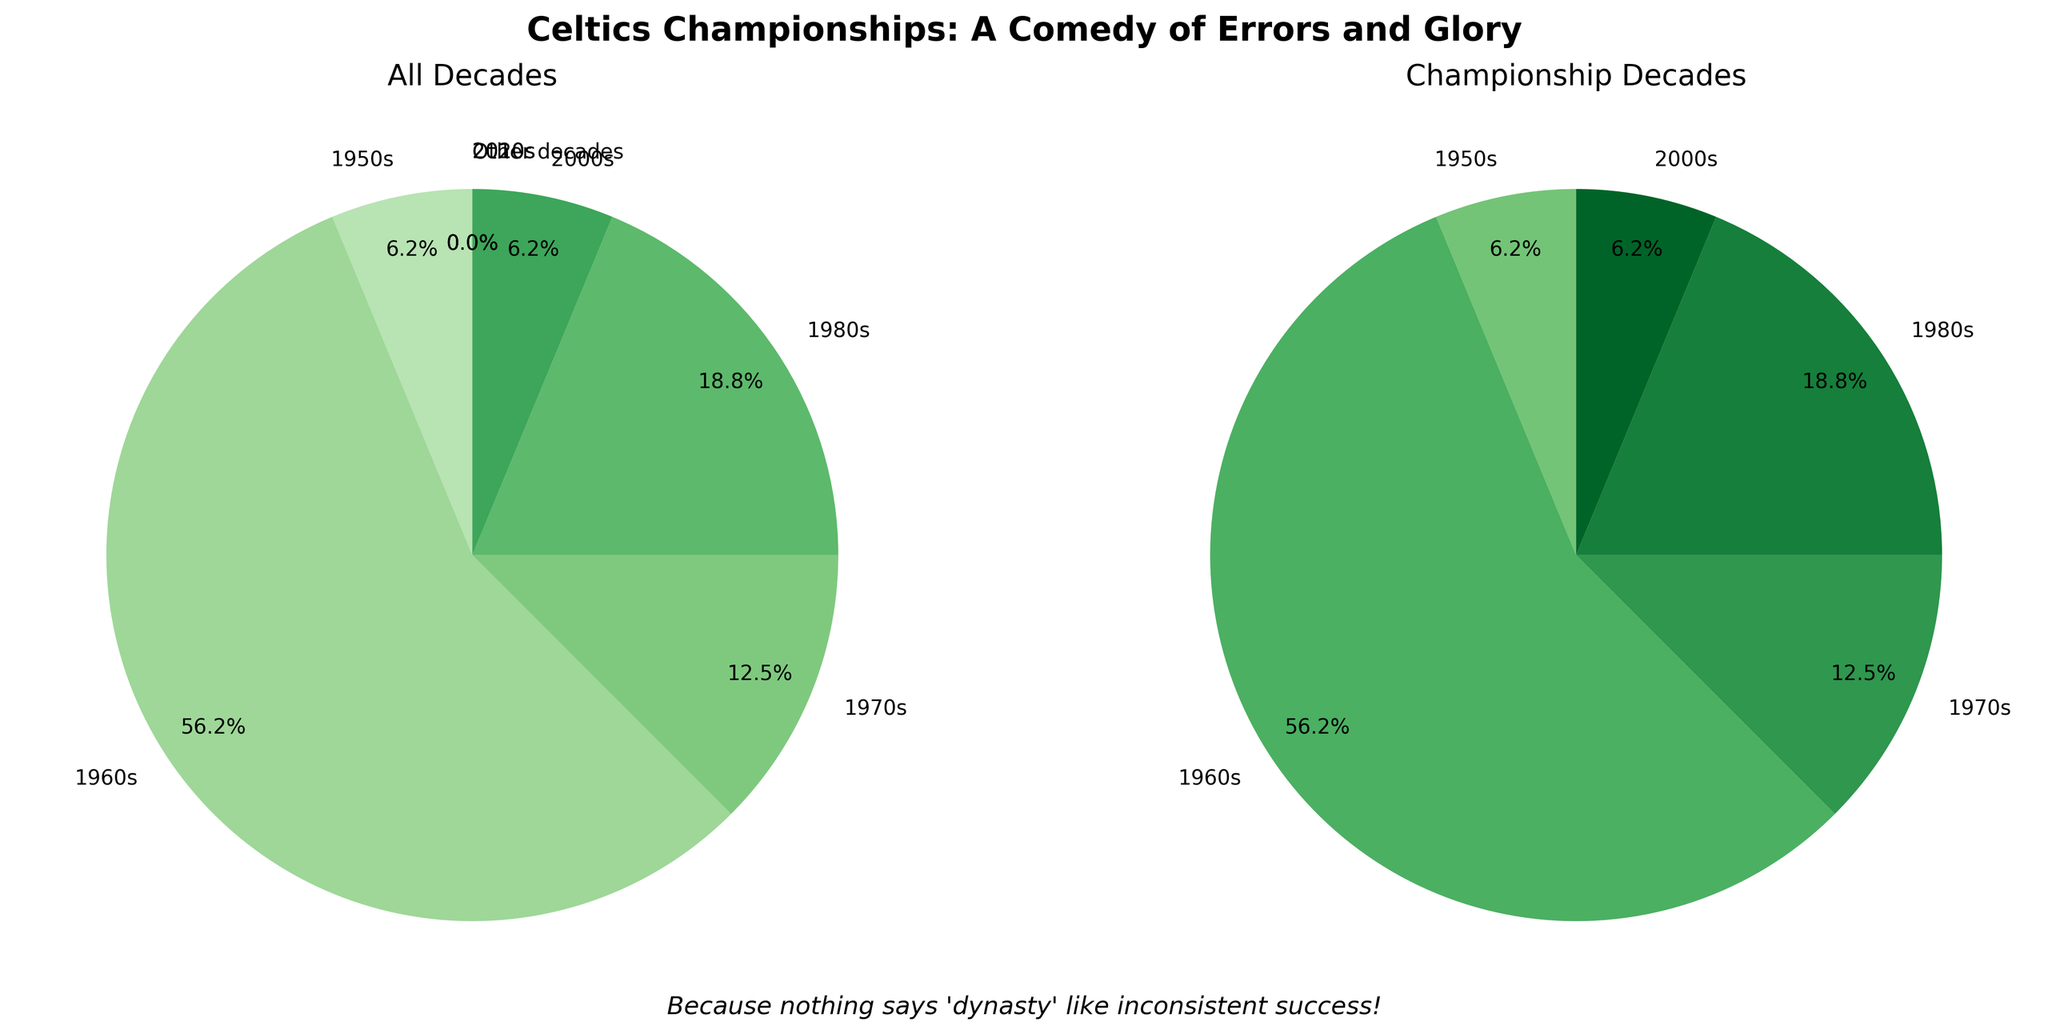Which decade has the highest percentage of championship wins? The pie chart on the left shows that the 1960s section is the largest, and looking at the percentages, the 1960s account for 75% of the championships.
Answer: 1960s How many more championships were won in the 1960s compared to the 1980s? On the pie chart showing championship decades, the 1960s section accounts for 9 wins while the 1980s section shows 3 wins. The difference is 9 - 3 = 6 championships.
Answer: 6 What percentage of championships were won before 1980? The chart indicates 1 championship in the 1950s, 9 in the 1960s, and 2 in the 1970s. Summing gives 1 + 9 + 2 = 12 championships out of a total of 16. Thus, the percentage is (12 / 16) * 100 = 75%.
Answer: 75% Which decades have no championships? Both pie charts show '2010s', '2020s', and 'Other decades' having 0 championships, evident from the absence of these labels in the right pie chart.
Answer: 2010s, 2020s, Other decades If the Celtics were to win a championship in the current decade (2020s), what would be the new percentage for the 1960s? Currently, the 1960s have 9 out of 16 championships, which is 56.25%. Adding one win in the 2020s makes the new total 17. The new percentage for the 1960s is (9 / 17) * 100 ≈ 52.9%.
Answer: 52.9% How many different decades have the Celtics won championships in? The pie chart on the right shows separate sections for the 1950s, 1960s, 1970s, 1980s, and 2000s, which means there are 5 different decades.
Answer: 5 What is the combined percentage of championships won in the 1950s and 2000s? The left pie chart shows the 1950s and 2000s each have won 1 championship out of 16, giving them individually 6.25%. Combined, this is 6.25% + 6.25% = 12.5%.
Answer: 12.5% 